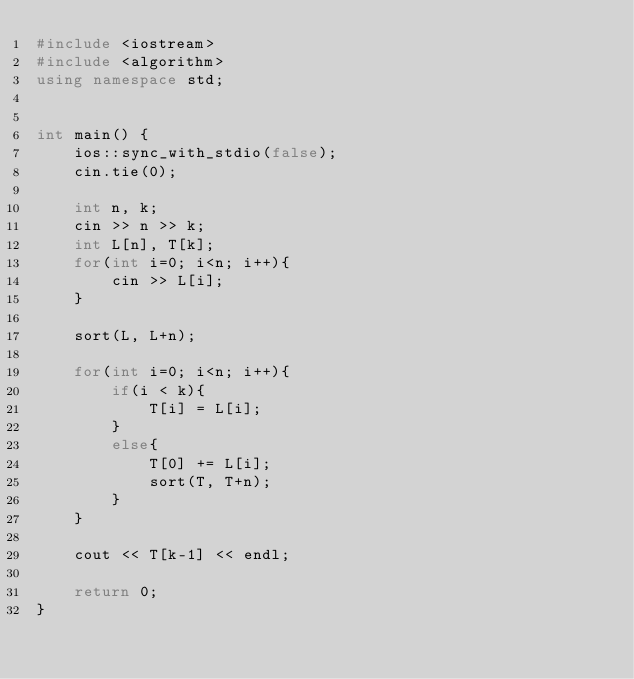<code> <loc_0><loc_0><loc_500><loc_500><_C++_>#include <iostream>
#include <algorithm>
using namespace std;
 

int main() {
    ios::sync_with_stdio(false);
    cin.tie(0);

	int n, k;
	cin >> n >> k;
	int L[n], T[k];
	for(int i=0; i<n; i++){
		cin >> L[i];	
	}
	
	sort(L, L+n);
	
	for(int i=0; i<n; i++){
		if(i < k){
			T[i] = L[i];
		}
		else{
			T[0] += L[i];
			sort(T, T+n);
		}
	}
	
	cout << T[k-1] << endl;
    
    return 0;
}</code> 